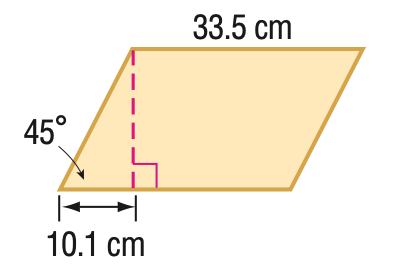Answer the mathemtical geometry problem and directly provide the correct option letter.
Question: Find the area of the parallelogram. Round to the nearest tenth if necessary.
Choices: A: 239.2 B: 338.4 C: 478.5 D: 586.0 B 